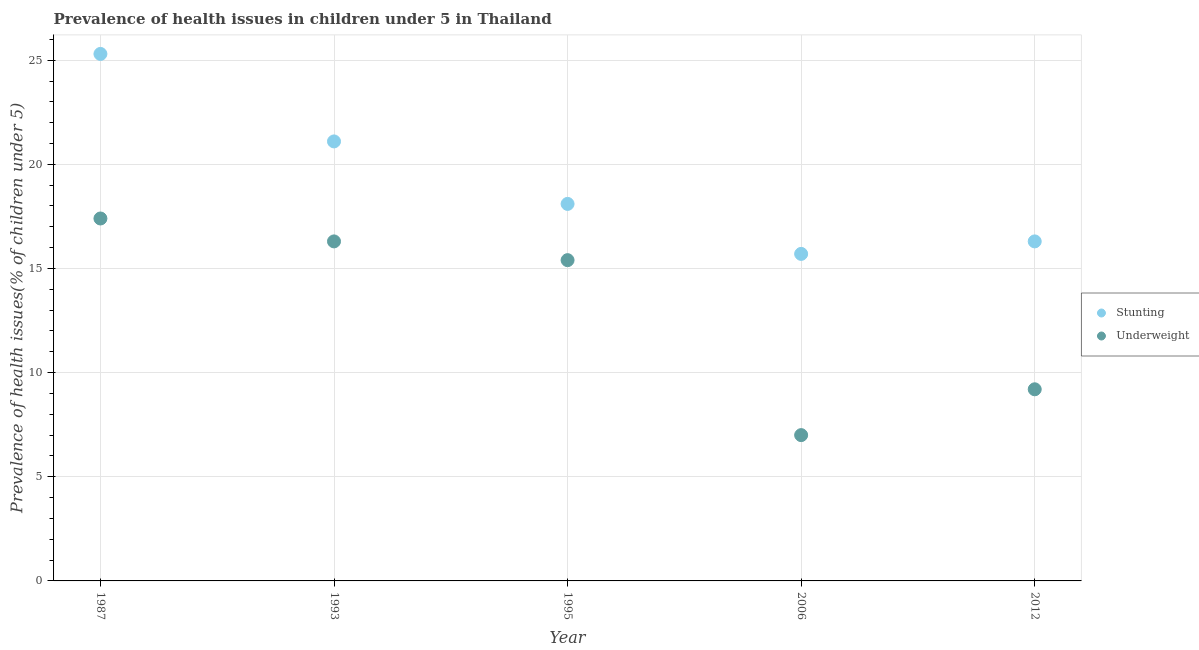What is the percentage of stunted children in 2006?
Ensure brevity in your answer.  15.7. Across all years, what is the maximum percentage of stunted children?
Offer a terse response. 25.3. Across all years, what is the minimum percentage of stunted children?
Your answer should be very brief. 15.7. In which year was the percentage of stunted children maximum?
Ensure brevity in your answer.  1987. What is the total percentage of underweight children in the graph?
Offer a very short reply. 65.3. What is the difference between the percentage of underweight children in 1987 and that in 2006?
Keep it short and to the point. 10.4. What is the difference between the percentage of stunted children in 2006 and the percentage of underweight children in 1993?
Give a very brief answer. -0.6. What is the average percentage of underweight children per year?
Provide a short and direct response. 13.06. In the year 1995, what is the difference between the percentage of stunted children and percentage of underweight children?
Give a very brief answer. 2.7. What is the ratio of the percentage of underweight children in 1987 to that in 2012?
Give a very brief answer. 1.89. Is the percentage of underweight children in 1993 less than that in 2012?
Your response must be concise. No. What is the difference between the highest and the second highest percentage of stunted children?
Keep it short and to the point. 4.2. What is the difference between the highest and the lowest percentage of stunted children?
Offer a very short reply. 9.6. In how many years, is the percentage of underweight children greater than the average percentage of underweight children taken over all years?
Provide a succinct answer. 3. Does the percentage of stunted children monotonically increase over the years?
Make the answer very short. No. Is the percentage of underweight children strictly greater than the percentage of stunted children over the years?
Give a very brief answer. No. How many dotlines are there?
Your answer should be very brief. 2. How many years are there in the graph?
Ensure brevity in your answer.  5. What is the difference between two consecutive major ticks on the Y-axis?
Offer a terse response. 5. Does the graph contain any zero values?
Keep it short and to the point. No. What is the title of the graph?
Provide a succinct answer. Prevalence of health issues in children under 5 in Thailand. What is the label or title of the Y-axis?
Your answer should be compact. Prevalence of health issues(% of children under 5). What is the Prevalence of health issues(% of children under 5) in Stunting in 1987?
Your answer should be very brief. 25.3. What is the Prevalence of health issues(% of children under 5) of Underweight in 1987?
Your answer should be very brief. 17.4. What is the Prevalence of health issues(% of children under 5) in Stunting in 1993?
Provide a succinct answer. 21.1. What is the Prevalence of health issues(% of children under 5) in Underweight in 1993?
Offer a very short reply. 16.3. What is the Prevalence of health issues(% of children under 5) of Stunting in 1995?
Your answer should be compact. 18.1. What is the Prevalence of health issues(% of children under 5) of Underweight in 1995?
Your response must be concise. 15.4. What is the Prevalence of health issues(% of children under 5) in Stunting in 2006?
Give a very brief answer. 15.7. What is the Prevalence of health issues(% of children under 5) in Underweight in 2006?
Provide a short and direct response. 7. What is the Prevalence of health issues(% of children under 5) of Stunting in 2012?
Provide a succinct answer. 16.3. What is the Prevalence of health issues(% of children under 5) in Underweight in 2012?
Make the answer very short. 9.2. Across all years, what is the maximum Prevalence of health issues(% of children under 5) of Stunting?
Your answer should be compact. 25.3. Across all years, what is the maximum Prevalence of health issues(% of children under 5) in Underweight?
Offer a terse response. 17.4. Across all years, what is the minimum Prevalence of health issues(% of children under 5) of Stunting?
Provide a short and direct response. 15.7. Across all years, what is the minimum Prevalence of health issues(% of children under 5) in Underweight?
Give a very brief answer. 7. What is the total Prevalence of health issues(% of children under 5) of Stunting in the graph?
Offer a very short reply. 96.5. What is the total Prevalence of health issues(% of children under 5) in Underweight in the graph?
Offer a very short reply. 65.3. What is the difference between the Prevalence of health issues(% of children under 5) in Underweight in 1987 and that in 1993?
Offer a terse response. 1.1. What is the difference between the Prevalence of health issues(% of children under 5) in Stunting in 1987 and that in 1995?
Make the answer very short. 7.2. What is the difference between the Prevalence of health issues(% of children under 5) in Underweight in 1987 and that in 2006?
Your answer should be very brief. 10.4. What is the difference between the Prevalence of health issues(% of children under 5) in Underweight in 1987 and that in 2012?
Offer a terse response. 8.2. What is the difference between the Prevalence of health issues(% of children under 5) in Stunting in 1993 and that in 1995?
Offer a terse response. 3. What is the difference between the Prevalence of health issues(% of children under 5) of Stunting in 1993 and that in 2006?
Ensure brevity in your answer.  5.4. What is the difference between the Prevalence of health issues(% of children under 5) in Stunting in 1995 and that in 2006?
Your answer should be compact. 2.4. What is the difference between the Prevalence of health issues(% of children under 5) of Underweight in 1995 and that in 2012?
Provide a short and direct response. 6.2. What is the difference between the Prevalence of health issues(% of children under 5) of Stunting in 1987 and the Prevalence of health issues(% of children under 5) of Underweight in 1993?
Offer a terse response. 9. What is the difference between the Prevalence of health issues(% of children under 5) in Stunting in 1987 and the Prevalence of health issues(% of children under 5) in Underweight in 2012?
Offer a terse response. 16.1. What is the difference between the Prevalence of health issues(% of children under 5) in Stunting in 1993 and the Prevalence of health issues(% of children under 5) in Underweight in 1995?
Provide a succinct answer. 5.7. What is the difference between the Prevalence of health issues(% of children under 5) in Stunting in 1993 and the Prevalence of health issues(% of children under 5) in Underweight in 2012?
Ensure brevity in your answer.  11.9. What is the difference between the Prevalence of health issues(% of children under 5) of Stunting in 1995 and the Prevalence of health issues(% of children under 5) of Underweight in 2006?
Provide a short and direct response. 11.1. What is the difference between the Prevalence of health issues(% of children under 5) of Stunting in 1995 and the Prevalence of health issues(% of children under 5) of Underweight in 2012?
Your response must be concise. 8.9. What is the average Prevalence of health issues(% of children under 5) of Stunting per year?
Ensure brevity in your answer.  19.3. What is the average Prevalence of health issues(% of children under 5) in Underweight per year?
Offer a terse response. 13.06. In the year 1995, what is the difference between the Prevalence of health issues(% of children under 5) of Stunting and Prevalence of health issues(% of children under 5) of Underweight?
Your answer should be very brief. 2.7. In the year 2006, what is the difference between the Prevalence of health issues(% of children under 5) of Stunting and Prevalence of health issues(% of children under 5) of Underweight?
Ensure brevity in your answer.  8.7. In the year 2012, what is the difference between the Prevalence of health issues(% of children under 5) of Stunting and Prevalence of health issues(% of children under 5) of Underweight?
Offer a very short reply. 7.1. What is the ratio of the Prevalence of health issues(% of children under 5) in Stunting in 1987 to that in 1993?
Give a very brief answer. 1.2. What is the ratio of the Prevalence of health issues(% of children under 5) of Underweight in 1987 to that in 1993?
Keep it short and to the point. 1.07. What is the ratio of the Prevalence of health issues(% of children under 5) in Stunting in 1987 to that in 1995?
Offer a terse response. 1.4. What is the ratio of the Prevalence of health issues(% of children under 5) of Underweight in 1987 to that in 1995?
Offer a very short reply. 1.13. What is the ratio of the Prevalence of health issues(% of children under 5) in Stunting in 1987 to that in 2006?
Your answer should be compact. 1.61. What is the ratio of the Prevalence of health issues(% of children under 5) in Underweight in 1987 to that in 2006?
Provide a short and direct response. 2.49. What is the ratio of the Prevalence of health issues(% of children under 5) of Stunting in 1987 to that in 2012?
Offer a very short reply. 1.55. What is the ratio of the Prevalence of health issues(% of children under 5) in Underweight in 1987 to that in 2012?
Offer a very short reply. 1.89. What is the ratio of the Prevalence of health issues(% of children under 5) in Stunting in 1993 to that in 1995?
Your answer should be compact. 1.17. What is the ratio of the Prevalence of health issues(% of children under 5) of Underweight in 1993 to that in 1995?
Make the answer very short. 1.06. What is the ratio of the Prevalence of health issues(% of children under 5) in Stunting in 1993 to that in 2006?
Your answer should be very brief. 1.34. What is the ratio of the Prevalence of health issues(% of children under 5) of Underweight in 1993 to that in 2006?
Keep it short and to the point. 2.33. What is the ratio of the Prevalence of health issues(% of children under 5) in Stunting in 1993 to that in 2012?
Make the answer very short. 1.29. What is the ratio of the Prevalence of health issues(% of children under 5) of Underweight in 1993 to that in 2012?
Your answer should be compact. 1.77. What is the ratio of the Prevalence of health issues(% of children under 5) in Stunting in 1995 to that in 2006?
Ensure brevity in your answer.  1.15. What is the ratio of the Prevalence of health issues(% of children under 5) of Underweight in 1995 to that in 2006?
Make the answer very short. 2.2. What is the ratio of the Prevalence of health issues(% of children under 5) of Stunting in 1995 to that in 2012?
Provide a succinct answer. 1.11. What is the ratio of the Prevalence of health issues(% of children under 5) in Underweight in 1995 to that in 2012?
Provide a short and direct response. 1.67. What is the ratio of the Prevalence of health issues(% of children under 5) of Stunting in 2006 to that in 2012?
Your answer should be compact. 0.96. What is the ratio of the Prevalence of health issues(% of children under 5) of Underweight in 2006 to that in 2012?
Your response must be concise. 0.76. What is the difference between the highest and the second highest Prevalence of health issues(% of children under 5) in Stunting?
Provide a succinct answer. 4.2. What is the difference between the highest and the lowest Prevalence of health issues(% of children under 5) of Underweight?
Your answer should be very brief. 10.4. 